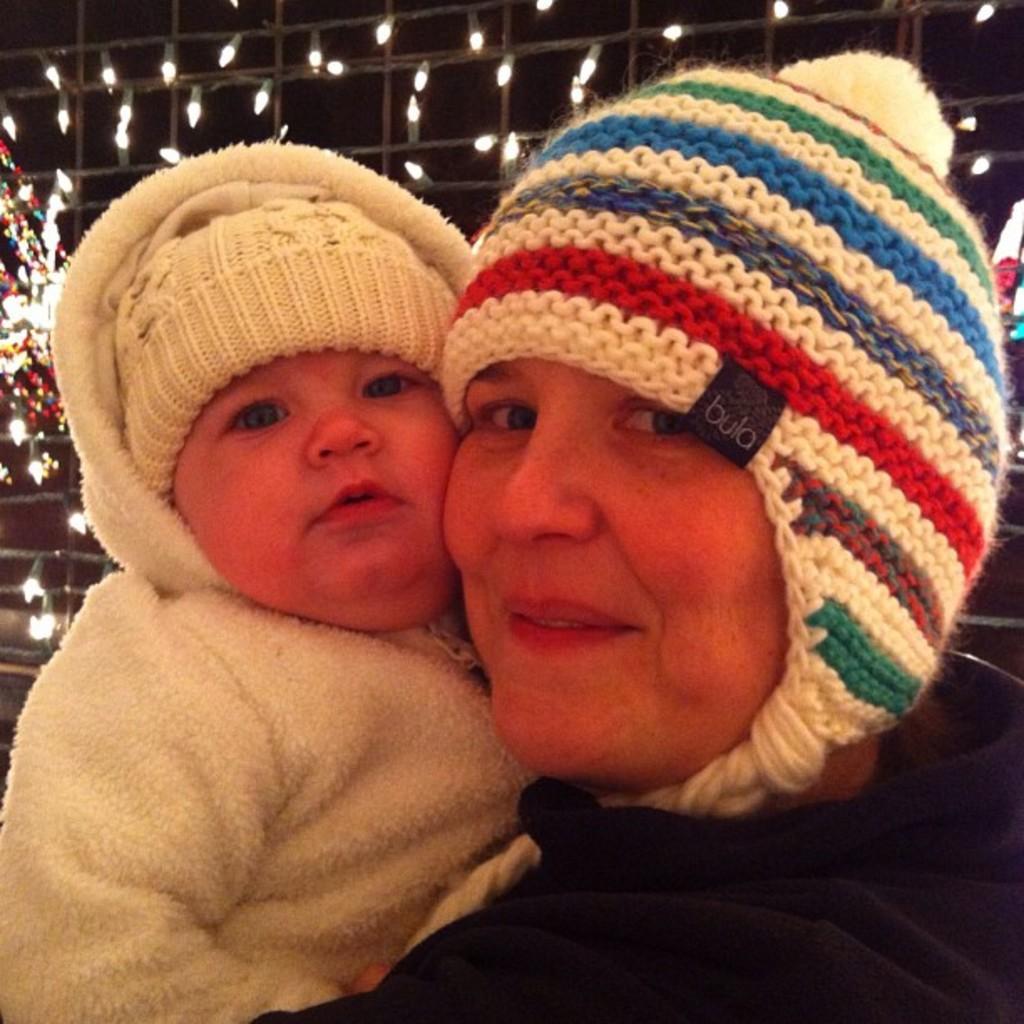How would you summarize this image in a sentence or two? In this image I can see a woman and a child in the front. I can see both of them are wearing caps and jackets. In the background I can see number of lights. 